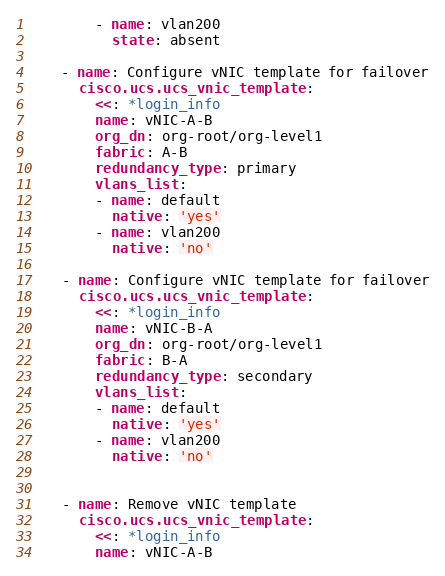Convert code to text. <code><loc_0><loc_0><loc_500><loc_500><_YAML_>        - name: vlan200
          state: absent

    - name: Configure vNIC template for failover
      cisco.ucs.ucs_vnic_template:
        <<: *login_info
        name: vNIC-A-B
        org_dn: org-root/org-level1
        fabric: A-B
        redundancy_type: primary
        vlans_list:
        - name: default
          native: 'yes'
        - name: vlan200
          native: 'no'

    - name: Configure vNIC template for failover
      cisco.ucs.ucs_vnic_template:
        <<: *login_info
        name: vNIC-B-A
        org_dn: org-root/org-level1
        fabric: B-A
        redundancy_type: secondary
        vlans_list:
        - name: default
          native: 'yes'
        - name: vlan200
          native: 'no'


    - name: Remove vNIC template
      cisco.ucs.ucs_vnic_template:
        <<: *login_info
        name: vNIC-A-B</code> 